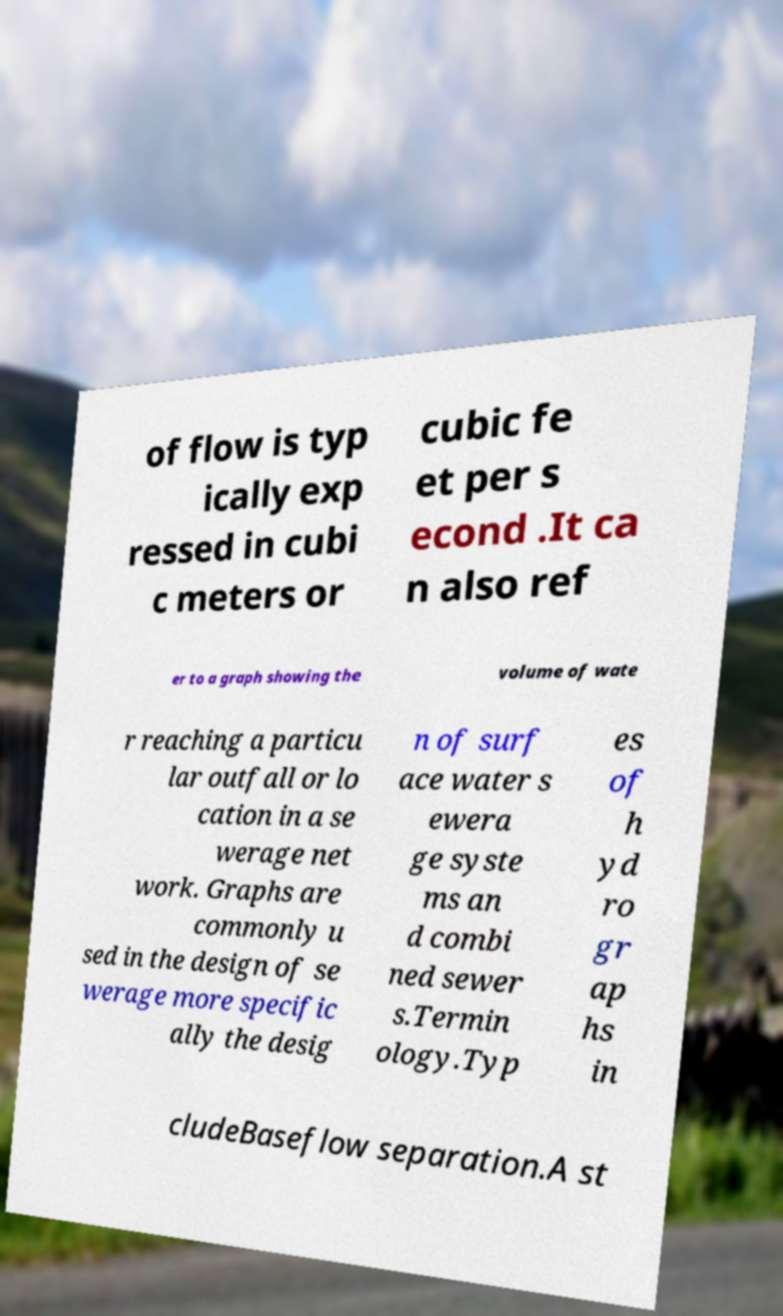There's text embedded in this image that I need extracted. Can you transcribe it verbatim? of flow is typ ically exp ressed in cubi c meters or cubic fe et per s econd .It ca n also ref er to a graph showing the volume of wate r reaching a particu lar outfall or lo cation in a se werage net work. Graphs are commonly u sed in the design of se werage more specific ally the desig n of surf ace water s ewera ge syste ms an d combi ned sewer s.Termin ology.Typ es of h yd ro gr ap hs in cludeBaseflow separation.A st 